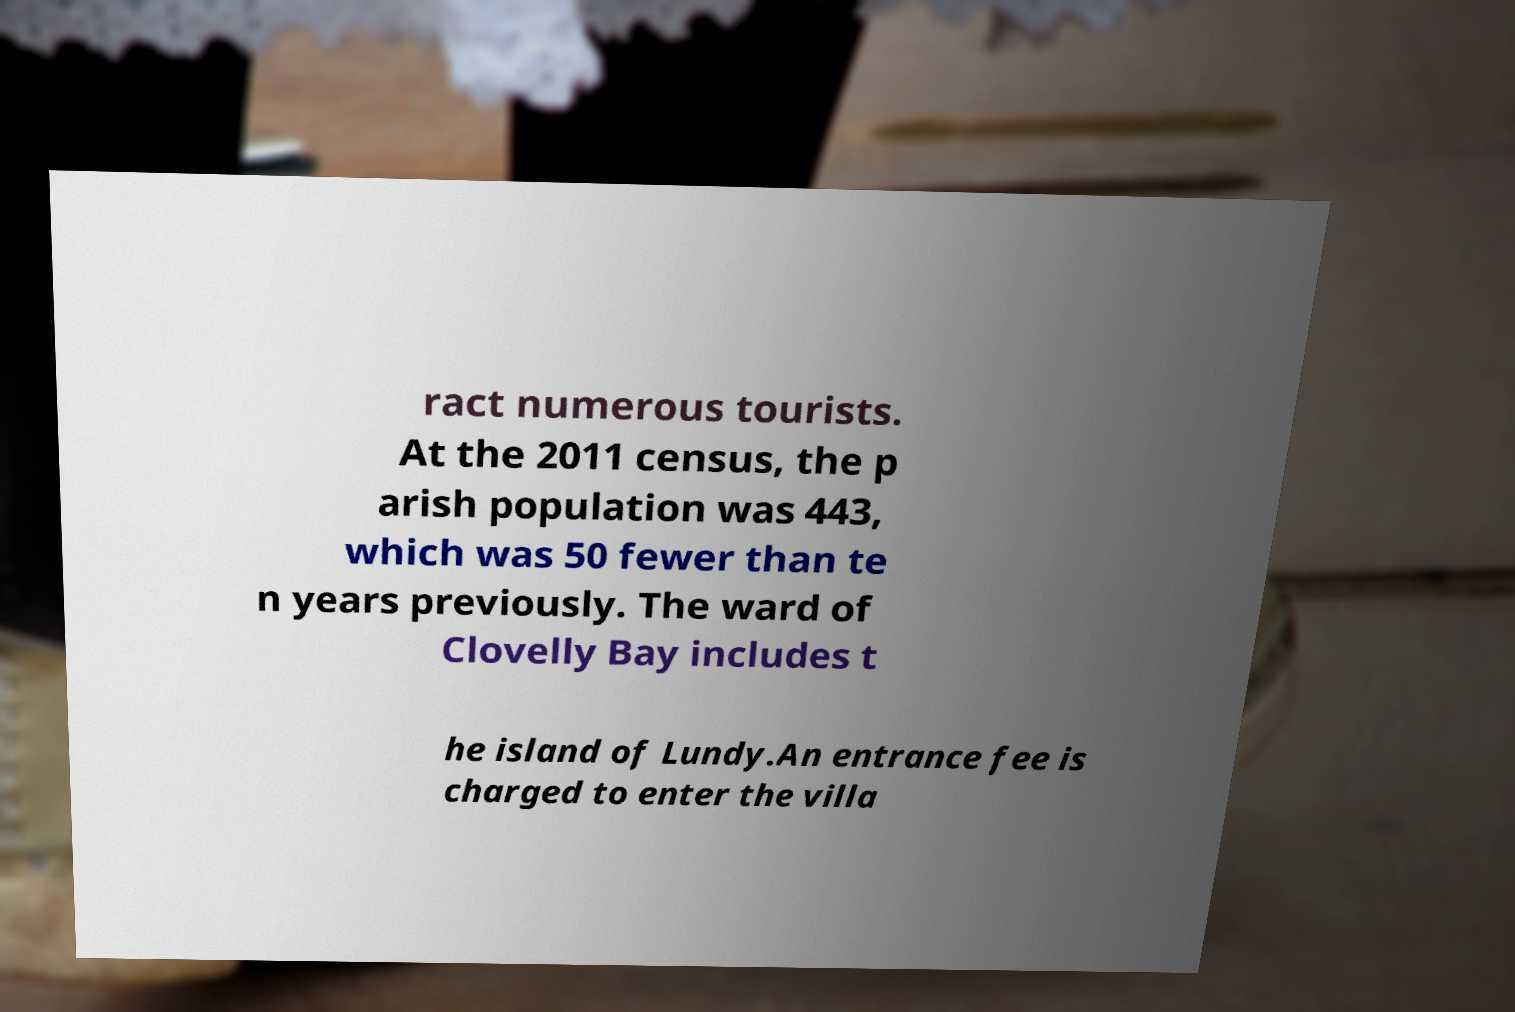Could you assist in decoding the text presented in this image and type it out clearly? ract numerous tourists. At the 2011 census, the p arish population was 443, which was 50 fewer than te n years previously. The ward of Clovelly Bay includes t he island of Lundy.An entrance fee is charged to enter the villa 